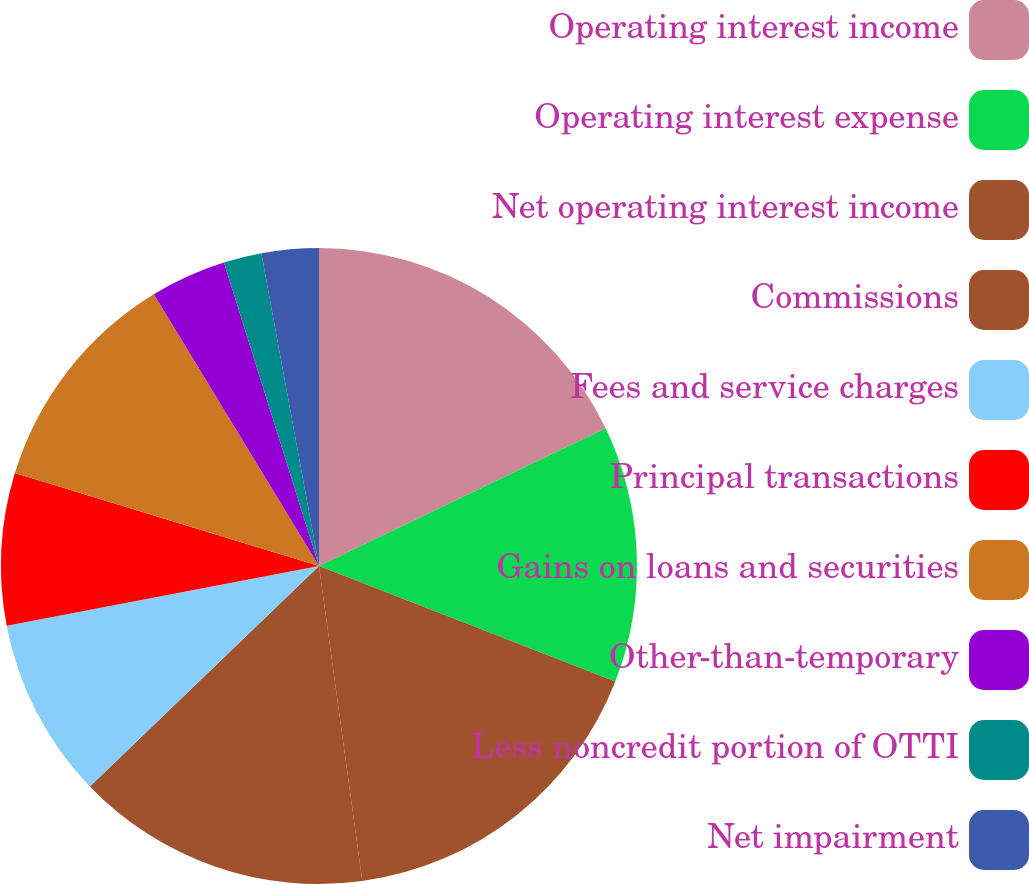Convert chart to OTSL. <chart><loc_0><loc_0><loc_500><loc_500><pie_chart><fcel>Operating interest income<fcel>Operating interest expense<fcel>Net operating interest income<fcel>Commissions<fcel>Fees and service charges<fcel>Principal transactions<fcel>Gains on loans and securities<fcel>Other-than-temporary<fcel>Less noncredit portion of OTTI<fcel>Net impairment<nl><fcel>17.87%<fcel>13.04%<fcel>16.91%<fcel>14.98%<fcel>9.18%<fcel>7.73%<fcel>11.59%<fcel>3.86%<fcel>1.93%<fcel>2.9%<nl></chart> 